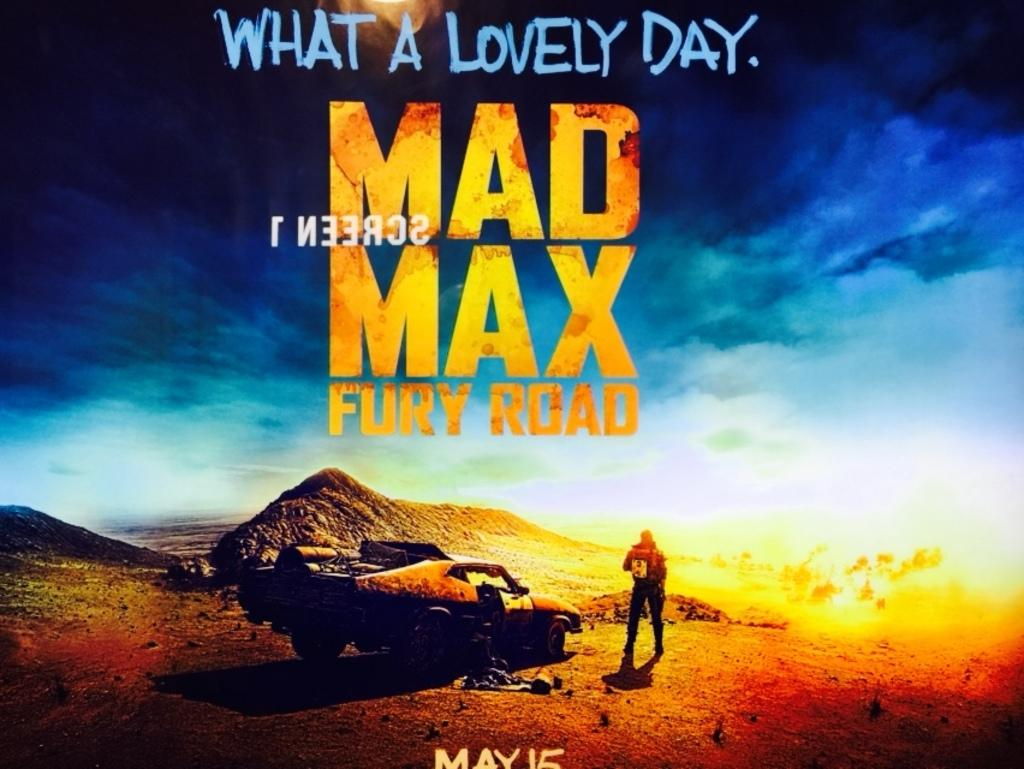<image>
Create a compact narrative representing the image presented. A movie poster where a man stands next to his car with the words MAD MAX in bright yellow 